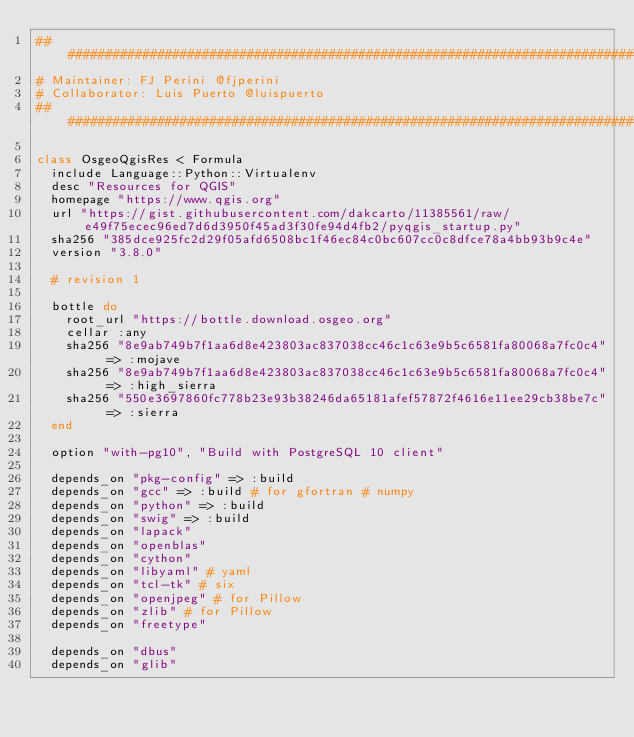<code> <loc_0><loc_0><loc_500><loc_500><_Ruby_>################################################################################
# Maintainer: FJ Perini @fjperini
# Collaborator: Luis Puerto @luispuerto
################################################################################

class OsgeoQgisRes < Formula
  include Language::Python::Virtualenv
  desc "Resources for QGIS"
  homepage "https://www.qgis.org"
  url "https://gist.githubusercontent.com/dakcarto/11385561/raw/e49f75ecec96ed7d6d3950f45ad3f30fe94d4fb2/pyqgis_startup.py"
  sha256 "385dce925fc2d29f05afd6508bc1f46ec84c0bc607cc0c8dfce78a4bb93b9c4e"
  version "3.8.0"

  # revision 1

  bottle do
    root_url "https://bottle.download.osgeo.org"
    cellar :any
    sha256 "8e9ab749b7f1aa6d8e423803ac837038cc46c1c63e9b5c6581fa80068a7fc0c4" => :mojave
    sha256 "8e9ab749b7f1aa6d8e423803ac837038cc46c1c63e9b5c6581fa80068a7fc0c4" => :high_sierra
    sha256 "550e3697860fc778b23e93b38246da65181afef57872f4616e11ee29cb38be7c" => :sierra
  end

  option "with-pg10", "Build with PostgreSQL 10 client"

  depends_on "pkg-config" => :build
  depends_on "gcc" => :build # for gfortran # numpy
  depends_on "python" => :build
  depends_on "swig" => :build
  depends_on "lapack"
  depends_on "openblas"
  depends_on "cython"
  depends_on "libyaml" # yaml
  depends_on "tcl-tk" # six
  depends_on "openjpeg" # for Pillow
  depends_on "zlib" # for Pillow
  depends_on "freetype"

  depends_on "dbus"
  depends_on "glib"</code> 